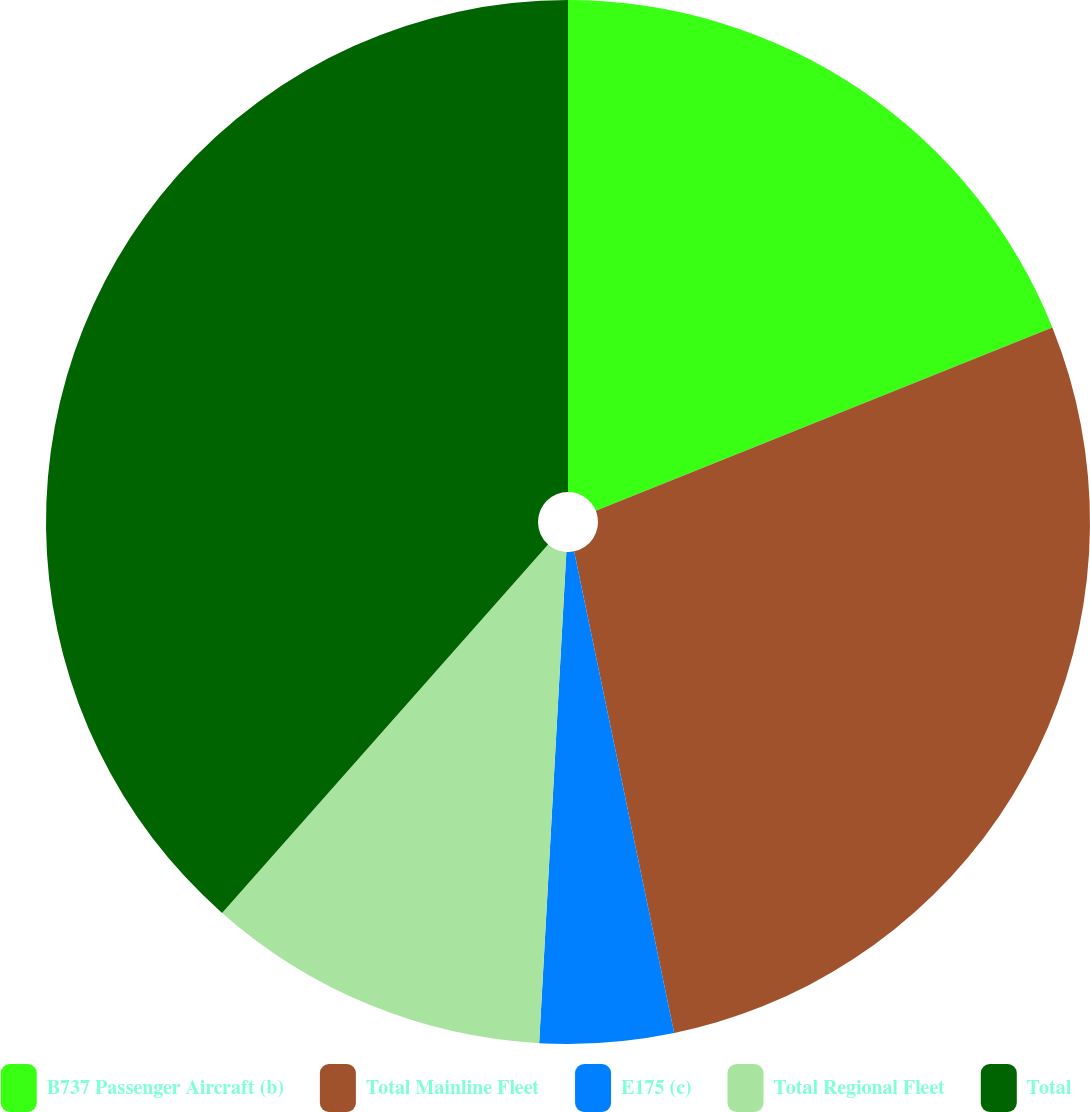Convert chart to OTSL. <chart><loc_0><loc_0><loc_500><loc_500><pie_chart><fcel>B737 Passenger Aircraft (b)<fcel>Total Mainline Fleet<fcel>E175 (c)<fcel>Total Regional Fleet<fcel>Total<nl><fcel>18.92%<fcel>27.82%<fcel>4.14%<fcel>10.65%<fcel>38.47%<nl></chart> 